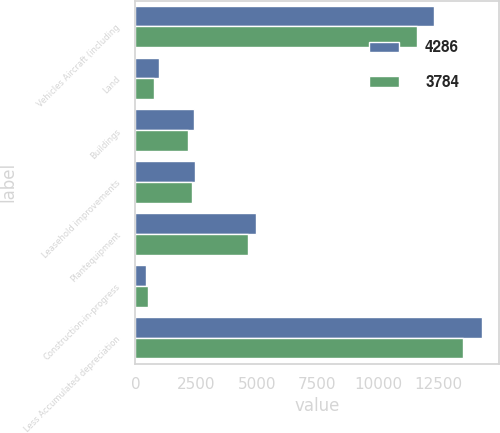Convert chart to OTSL. <chart><loc_0><loc_0><loc_500><loc_500><stacked_bar_chart><ecel><fcel>Vehicles Aircraft (including<fcel>Land<fcel>Buildings<fcel>Leasehold improvements<fcel>Plantequipment<fcel>Construction-in-progress<fcel>Less Accumulated depreciation<nl><fcel>4286<fcel>12289<fcel>968<fcel>2404<fcel>2469<fcel>4982<fcel>433<fcel>14268<nl><fcel>3784<fcel>11590<fcel>760<fcel>2164<fcel>2347<fcel>4641<fcel>539<fcel>13505<nl></chart> 